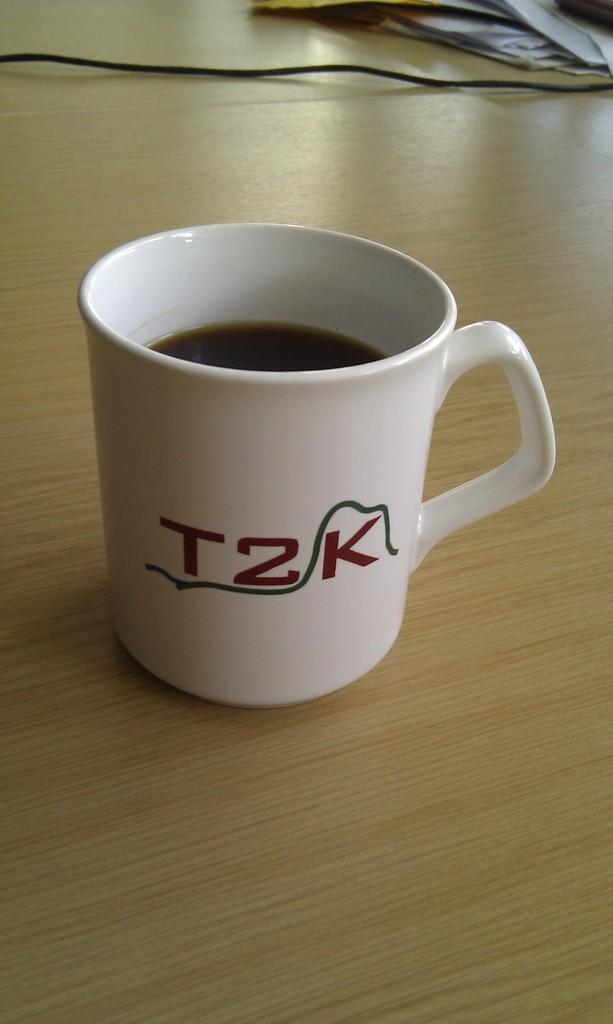What color is the teacup in the image? The teacup is white in color. What type of airport is visible in the image? There is no airport present in the image; it only features a white teacup. 